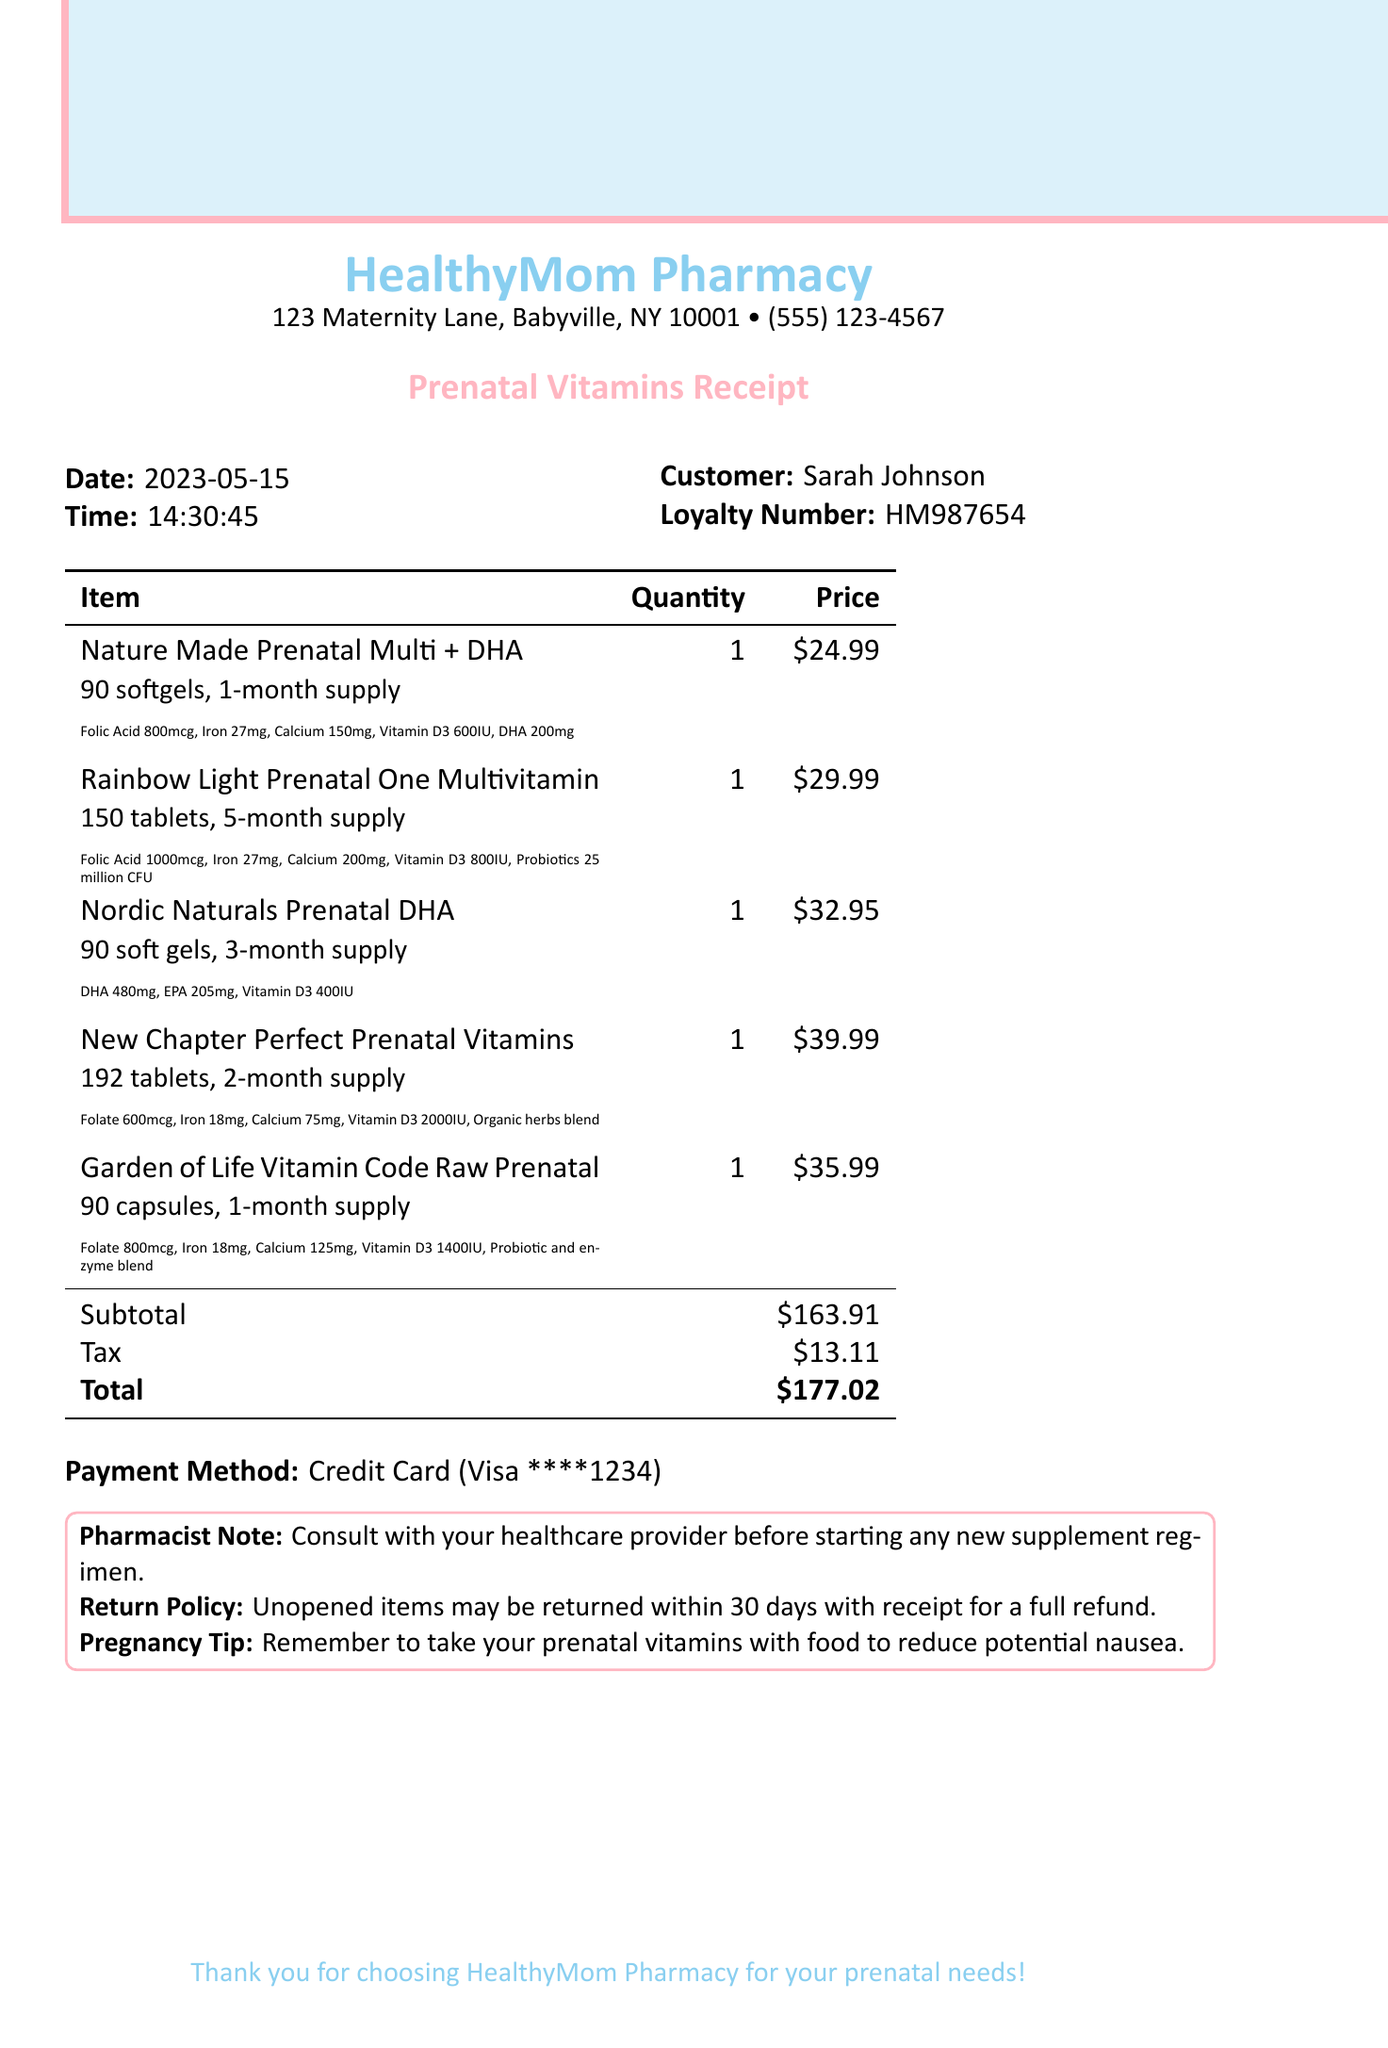what is the name of the store? The store name is prominently displayed at the top of the receipt.
Answer: HealthyMom Pharmacy what date was the purchase made? The date of the transaction is clearly listed in the receipt header.
Answer: 2023-05-15 how many softgels are included in the Nature Made Prenatal Multi + DHA? The description for this item specifies the quantity of softgels.
Answer: 90 softgels what is the total amount charged? The total amount is summarized at the end of the transaction with clear labeling.
Answer: $177.02 which vitamin has the highest amount of Folic Acid? By comparing the nutritional information of each item, we can determine which one contains the most Folic Acid.
Answer: Rainbow Light Prenatal One Multivitamin what is the pharmacist's recommendation? The pharmacist's note provides guidance on starting new supplements.
Answer: Consult with your healthcare provider before starting any new supplement regimen how many tablets are in the Rainbow Light Prenatal One Multivitamin? The item description specifies the number of tablets included in the bottle.
Answer: 150 tablets what is the return policy for unopened items? The additional information section contains details about returning items.
Answer: Unopened items may be returned within 30 days with receipt for a full refund 